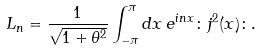Convert formula to latex. <formula><loc_0><loc_0><loc_500><loc_500>L _ { n } = \frac { 1 } { \sqrt { 1 + \theta ^ { 2 } } } \int _ { - \pi } ^ { \pi } d x \, e ^ { i n x } \colon j ^ { 2 } ( x ) \colon .</formula> 